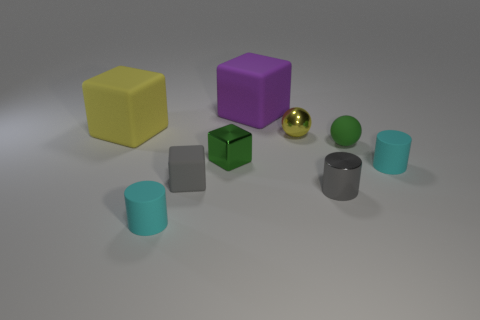Subtract all big purple cubes. How many cubes are left? 3 Subtract all blue balls. How many cyan cylinders are left? 2 Subtract all purple blocks. How many blocks are left? 3 Add 1 small gray matte cubes. How many objects exist? 10 Subtract all cylinders. How many objects are left? 6 Subtract 3 cubes. How many cubes are left? 1 Add 2 tiny green spheres. How many tiny green spheres exist? 3 Subtract 1 green spheres. How many objects are left? 8 Subtract all brown blocks. Subtract all green cylinders. How many blocks are left? 4 Subtract all tiny cyan cylinders. Subtract all small objects. How many objects are left? 0 